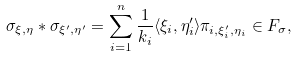<formula> <loc_0><loc_0><loc_500><loc_500>\sigma _ { \xi , \eta } * \sigma _ { \xi ^ { \prime } , \eta ^ { \prime } } = \sum _ { i = 1 } ^ { n } \frac { 1 } { k _ { i } } \langle \xi _ { i } , \eta ^ { \prime } _ { i } \rangle \pi _ { i , \xi ^ { \prime } _ { i } , \eta _ { i } } \in F _ { \sigma } ,</formula> 